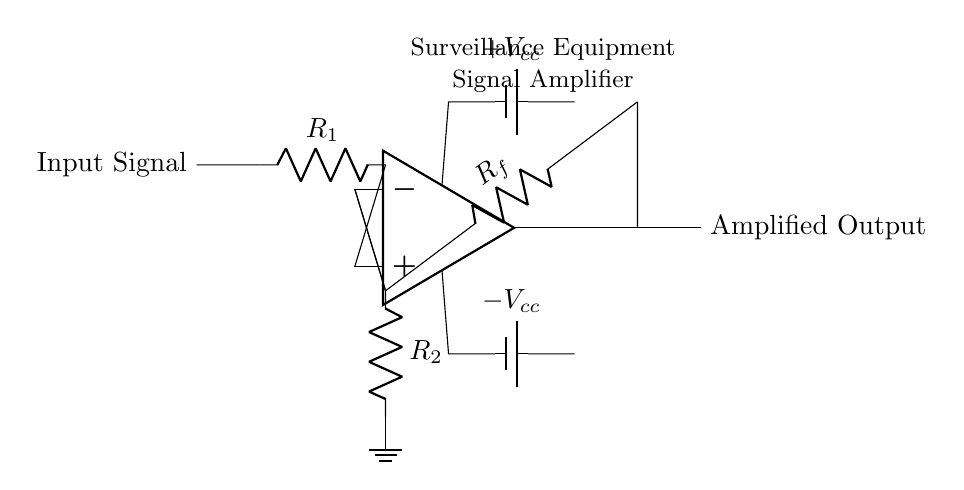What is the primary component used for amplification in this circuit? The primary component used for amplification is an operational amplifier, which is represented by the triangle symbol in the diagram.
Answer: Operational amplifier What is the purpose of resistor R1 in this circuit? Resistor R1 is used to limit the input current to the operational amplifier, affecting the gain of the circuit.
Answer: Current limiting What is the function of the feedback resistor Rf? The feedback resistor Rf is used to set the gain of the operational amplifier by creating a feedback loop that stabilizes the output signal.
Answer: Gain setting What are the voltage supply levels for the operational amplifier? The operational amplifier is supplied with positive and negative voltage levels of plus Vcc and minus Vcc, which provide the necessary power for operation.
Answer: Plus and minus Vcc How does the circuit affect the input signal? The circuit amplifies the input signal, producing an amplified output signal that is proportional to the input signal based on the gain determined by the resistors.
Answer: Amplification What type of equipment is this circuit commonly used in? This circuit is commonly used in surveillance equipment, where amplifying weak signals is essential for capturing clear audio or video.
Answer: Surveillance equipment What is connected to the output of the operational amplifier? The output of the operational amplifier is connected to the amplified output, which carries the significantly boosted signal to the next stage in the circuit or system.
Answer: Amplified output 